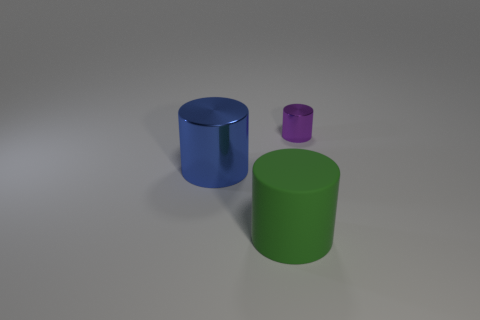Is the shape of the metal object that is in front of the purple thing the same as  the rubber object?
Offer a terse response. Yes. The metallic object that is in front of the shiny object right of the cylinder that is left of the big green thing is what shape?
Offer a terse response. Cylinder. There is a large cylinder that is behind the matte thing; what is it made of?
Provide a short and direct response. Metal. What is the color of the other thing that is the same size as the rubber object?
Make the answer very short. Blue. How many other things are there of the same shape as the large blue object?
Give a very brief answer. 2. Is the size of the rubber cylinder the same as the blue metal thing?
Keep it short and to the point. Yes. Is the number of large green things that are in front of the tiny thing greater than the number of large things that are left of the big metallic cylinder?
Your response must be concise. Yes. What number of other things are the same size as the blue metallic thing?
Provide a succinct answer. 1. Does the thing that is in front of the big blue metallic cylinder have the same color as the tiny thing?
Your answer should be compact. No. Are there more cylinders to the left of the small purple cylinder than blue matte spheres?
Give a very brief answer. Yes. 